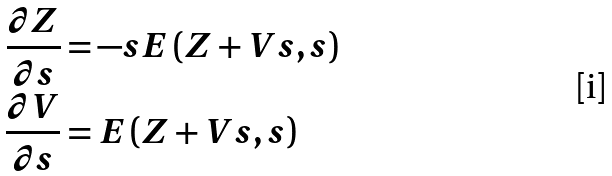Convert formula to latex. <formula><loc_0><loc_0><loc_500><loc_500>\frac { \partial Z } { \partial s } & = - s E \left ( Z + V s , s \right ) \\ \frac { \partial V } { \partial s } & = E \left ( Z + V s , s \right )</formula> 